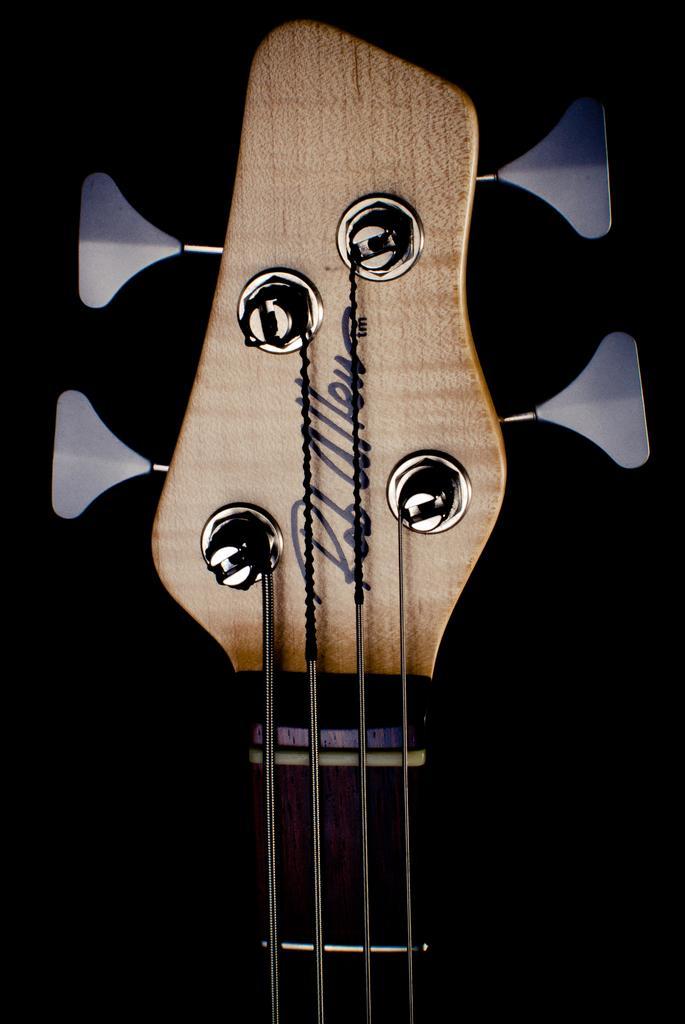Could you give a brief overview of what you see in this image? In this image, there is a picture of guitar, which is also visible half. 